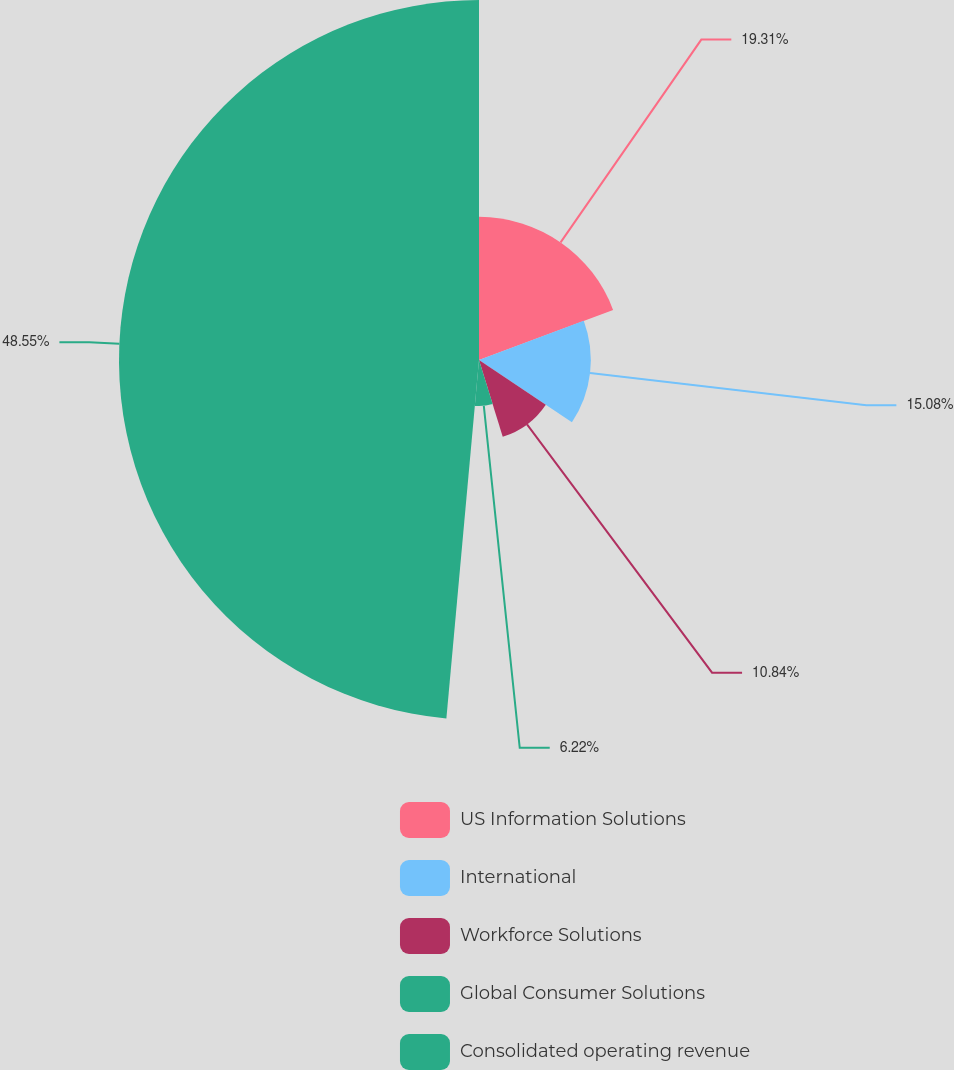Convert chart to OTSL. <chart><loc_0><loc_0><loc_500><loc_500><pie_chart><fcel>US Information Solutions<fcel>International<fcel>Workforce Solutions<fcel>Global Consumer Solutions<fcel>Consolidated operating revenue<nl><fcel>19.31%<fcel>15.08%<fcel>10.84%<fcel>6.22%<fcel>48.56%<nl></chart> 